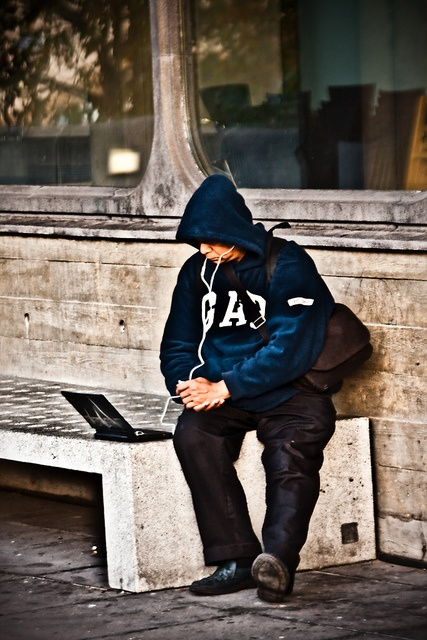Describe the objects in this image and their specific colors. I can see people in black, white, navy, and gray tones, bench in black, lightgray, darkgray, and tan tones, handbag in black, white, and gray tones, and laptop in black, lightgray, darkgray, and gray tones in this image. 